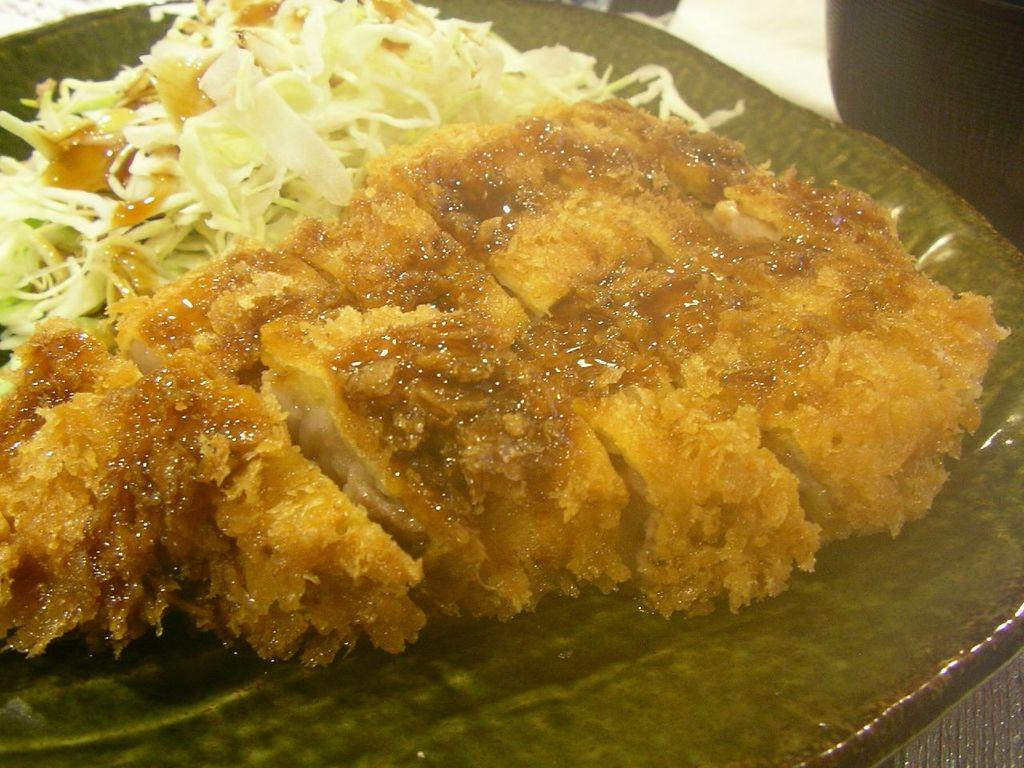What color is the plate that is visible in the image? There is a green plate in the image. What is on the green plate? The green plate contains a food item. Where is the black object located in the image? The black object is in the right top of the image. What is the color of the white object in the image? There is a white object in the image. Can you see a key hanging from the white object in the image? There is no key present in the image. Is there a cemetery visible in the background of the image? There is no cemetery present in the image. 